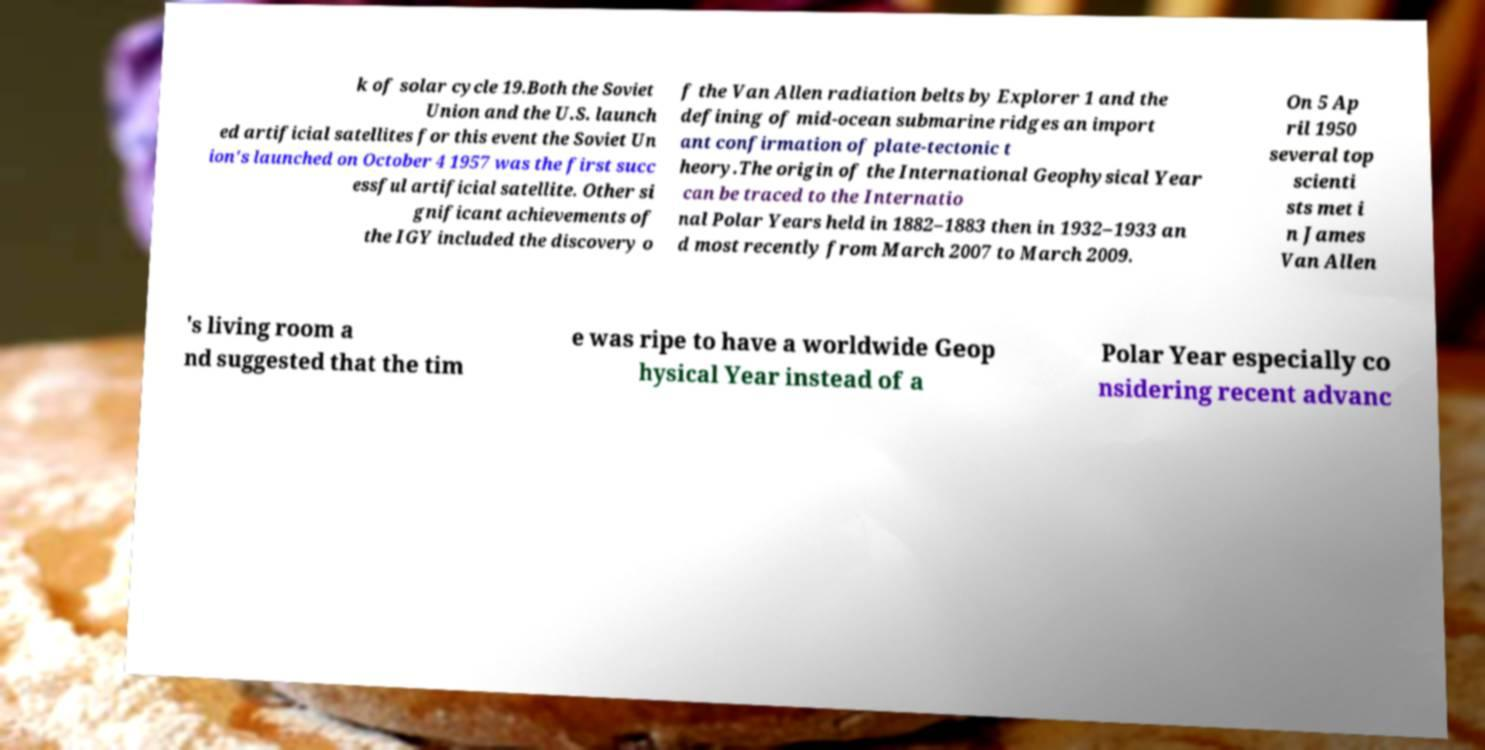Please read and relay the text visible in this image. What does it say? k of solar cycle 19.Both the Soviet Union and the U.S. launch ed artificial satellites for this event the Soviet Un ion's launched on October 4 1957 was the first succ essful artificial satellite. Other si gnificant achievements of the IGY included the discovery o f the Van Allen radiation belts by Explorer 1 and the defining of mid-ocean submarine ridges an import ant confirmation of plate-tectonic t heory.The origin of the International Geophysical Year can be traced to the Internatio nal Polar Years held in 1882–1883 then in 1932–1933 an d most recently from March 2007 to March 2009. On 5 Ap ril 1950 several top scienti sts met i n James Van Allen 's living room a nd suggested that the tim e was ripe to have a worldwide Geop hysical Year instead of a Polar Year especially co nsidering recent advanc 